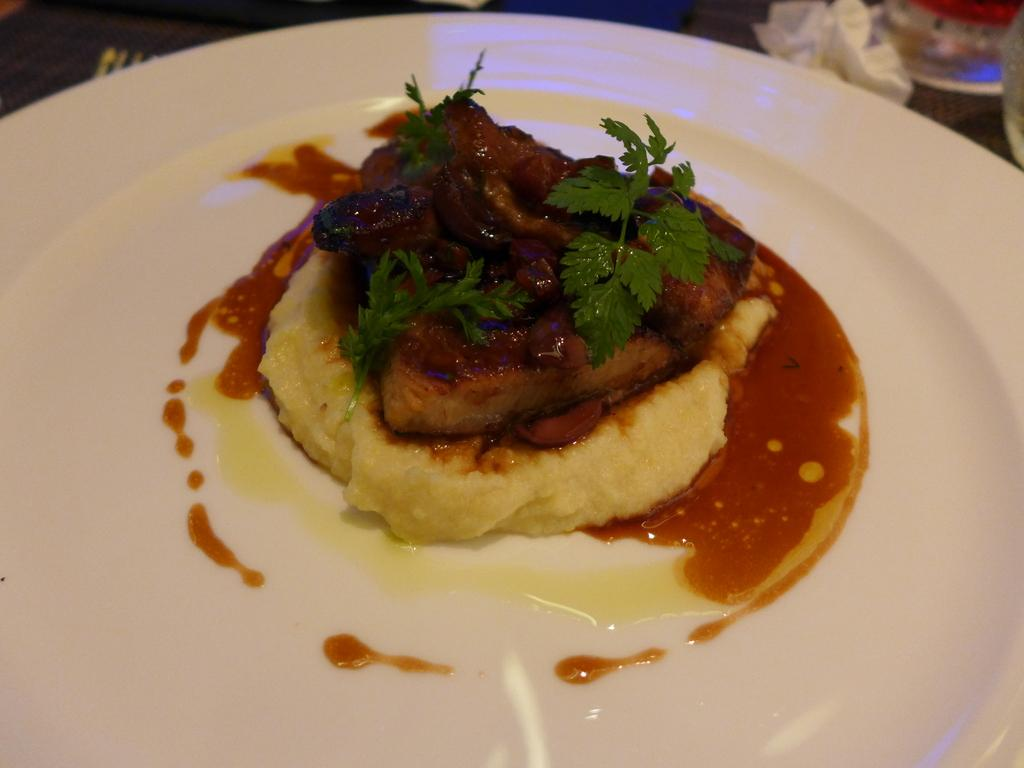What is present on the plate in the image? There are food items on the plate in the image. What type of yarn is being used to create the wrist in the image? There is no yarn or wrist present in the image; it features a plate with food items. 